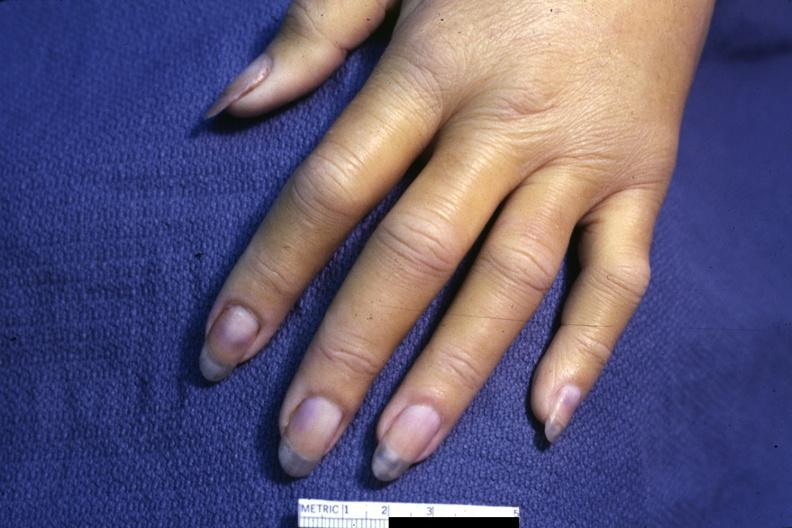s hand present?
Answer the question using a single word or phrase. Yes 